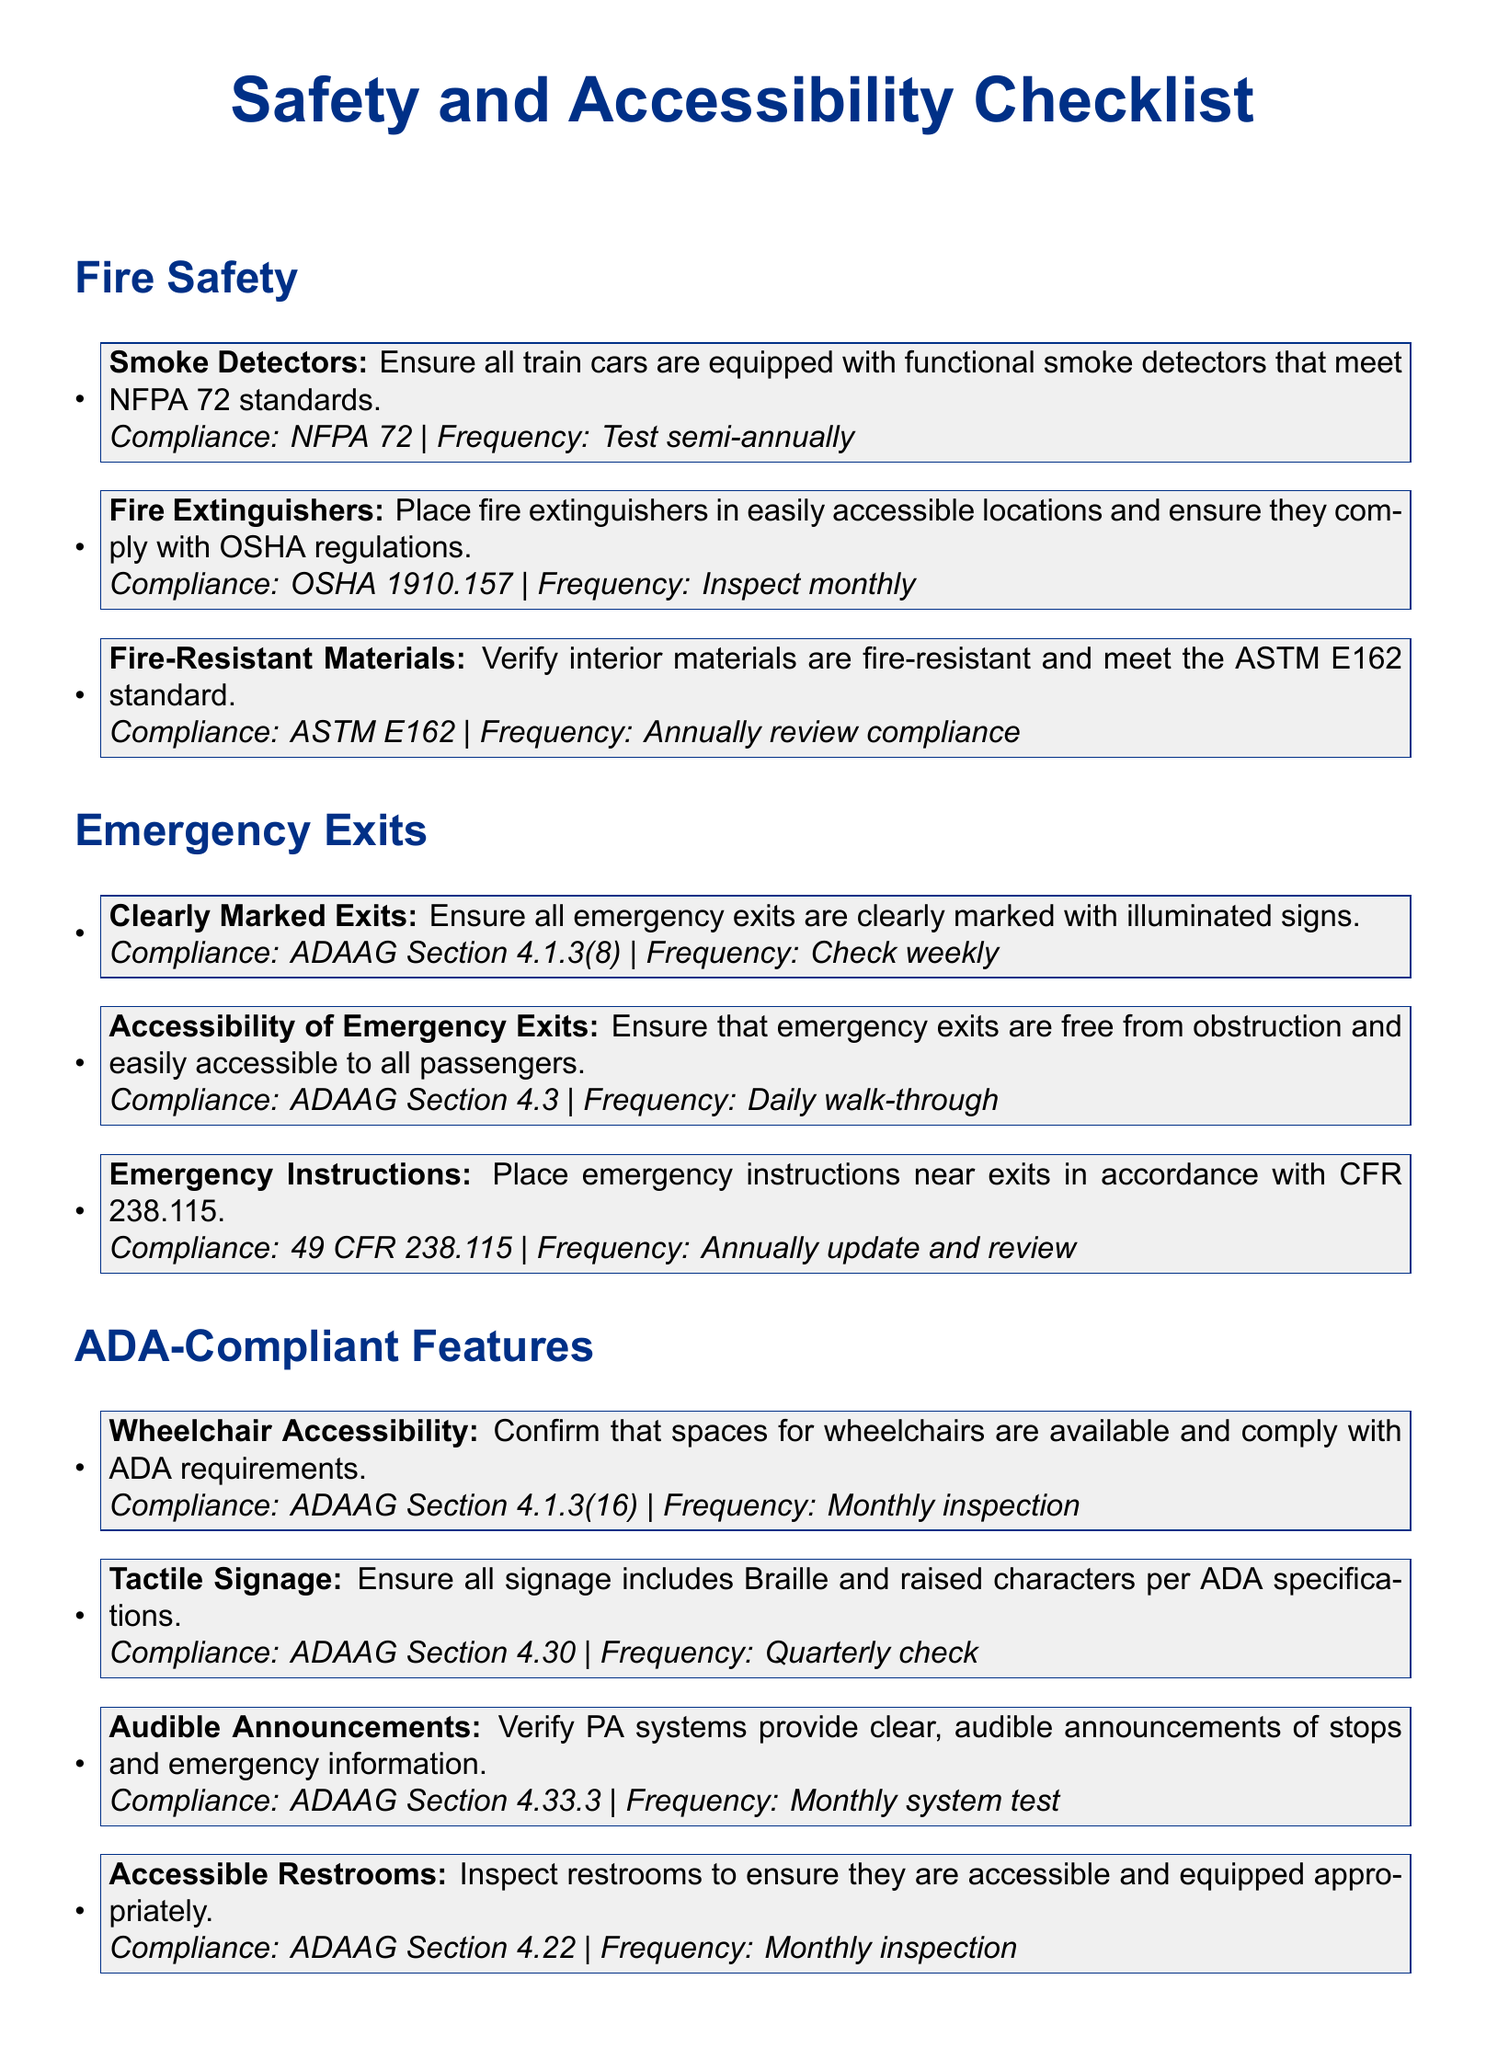what is the compliance standard for smoke detectors? The compliance standard for smoke detectors is NFPA 72.
Answer: NFPA 72 how often should fire extinguishers be inspected? Fire extinguishers should be inspected monthly.
Answer: monthly what section of the ADAAG refers to accessible emergency exits? The section of the ADAAG that refers to accessible emergency exits is Section 4.3.
Answer: Section 4.3 what feature must signage include per ADA specifications? Signage must include Braille and raised characters.
Answer: Braille and raised characters how frequently should wheelchair accessibility be inspected? Wheelchair accessibility should be inspected monthly.
Answer: monthly which compliance standard relates to fire-resistant materials? The compliance standard for fire-resistant materials is ASTM E162.
Answer: ASTM E162 how often should emergency instructions be updated and reviewed? Emergency instructions should be updated and reviewed annually.
Answer: annually what type of announcements must the PA system provide? The PA system must provide clear, audible announcements of stops and emergency information.
Answer: clear, audible announcements what document type is this checklist classified as? This checklist is classified as a Safety and Accessibility Checklist.
Answer: Safety and Accessibility Checklist 